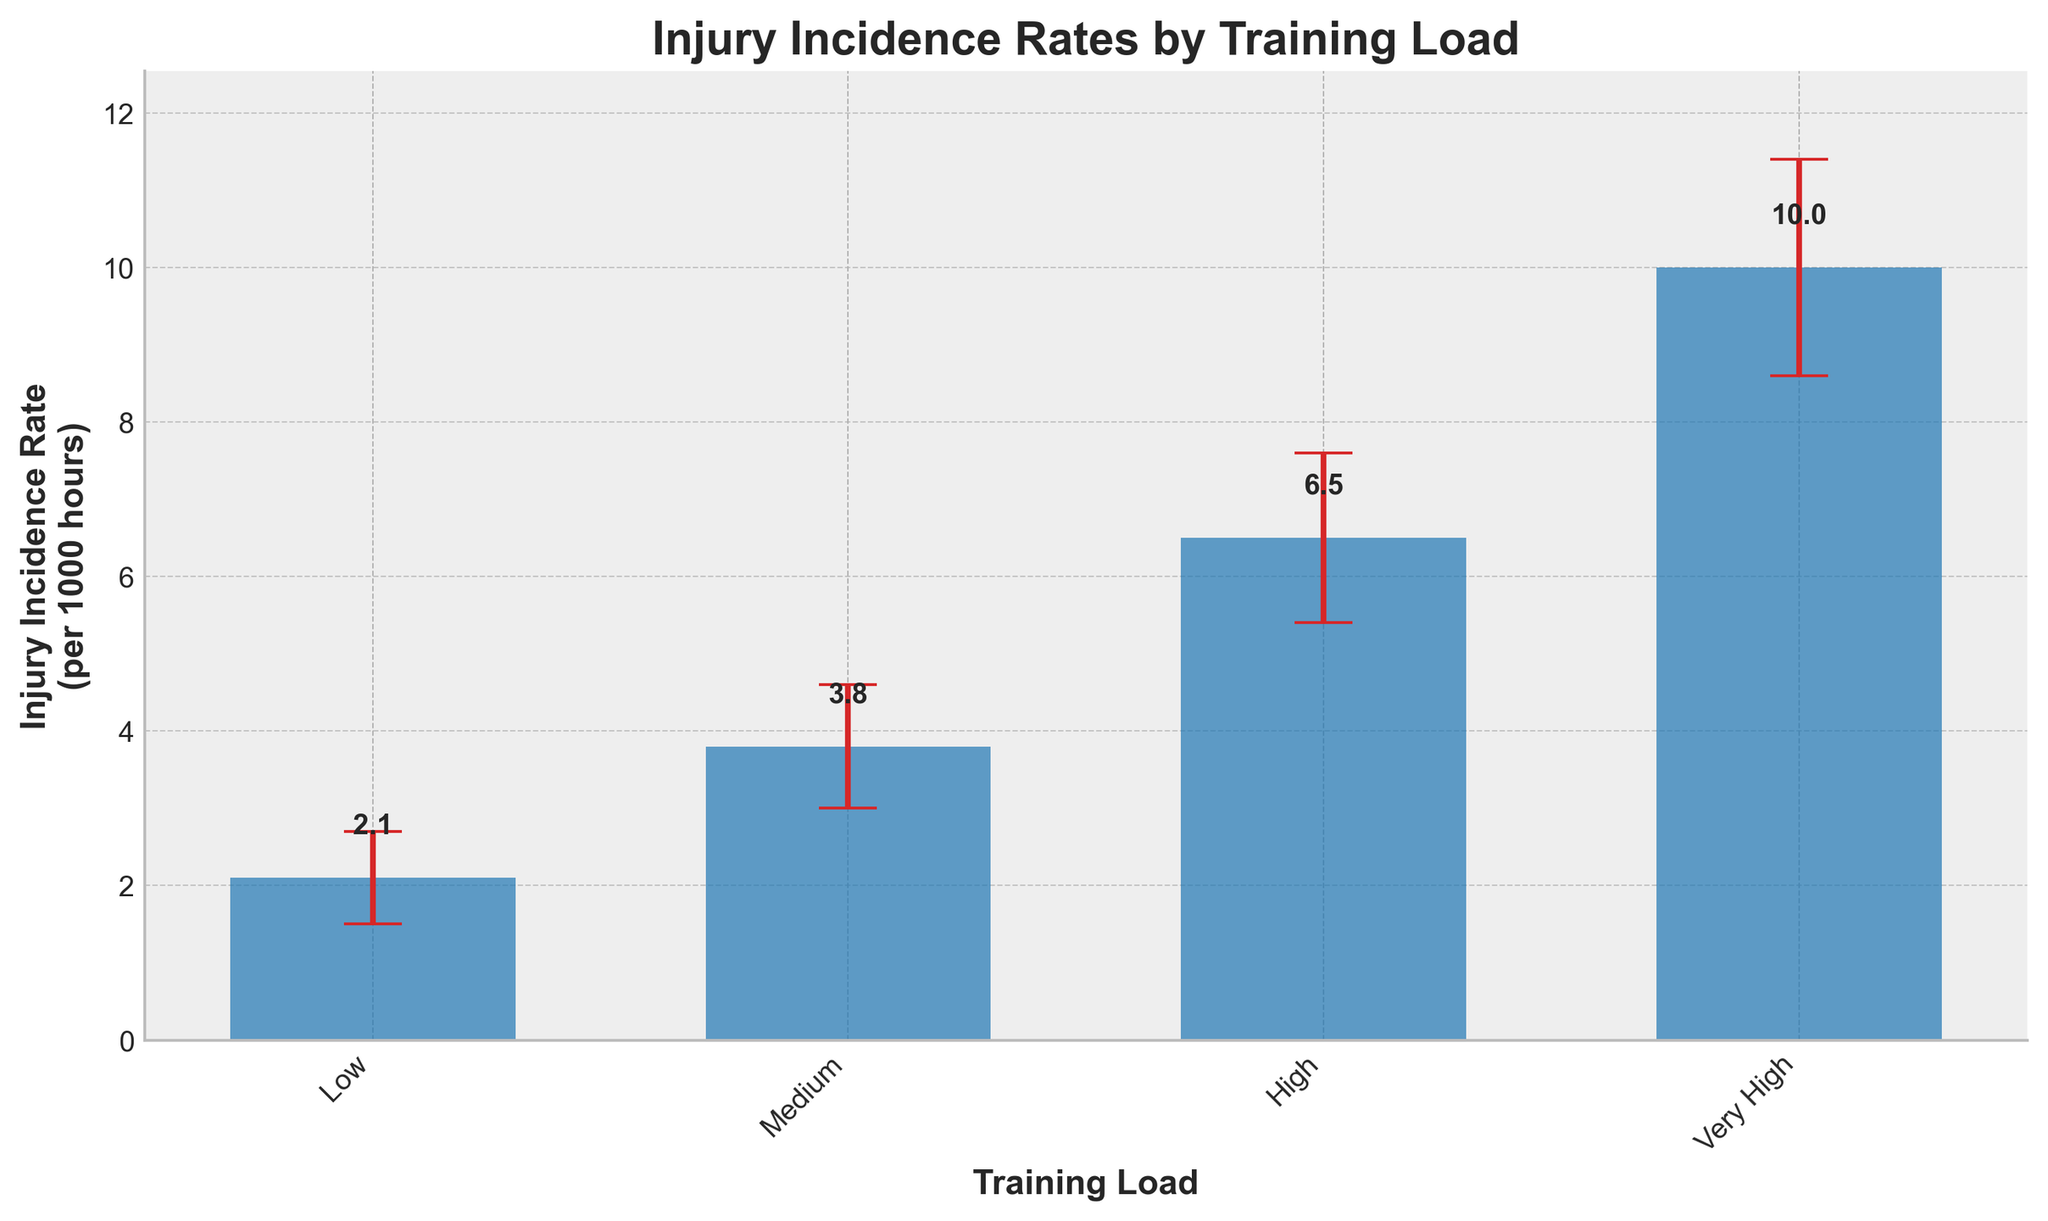What is the title of the plot? The title of the plot is located at the top and it clearly explains what the figure represents. In this case, it is "Injury Incidence Rates by Training Load".
Answer: Injury Incidence Rates by Training Load What does the y-axis represent? The y-axis label is present on the vertical line, indicating what the axis measures. Here, it is labeled "Injury Incidence Rate\n(per 1000 hours)".
Answer: Injury Incidence Rate (per 1000 hours) Which training load has the highest injury incidence rate? By looking at the height of the bars, we can see that the "Very High" training load bar is the tallest.
Answer: Very High What is the injury incidence rate for the "Medium" training load? The text on top of the bars shows the exact rates. For "Medium," it is 3.8 per 1000 hours.
Answer: 3.8 per 1000 hours By how much does the injury incidence rate increase from "Low" to "High" training load? Subtract the "Low" rate from the "High" rate using the values provided on the bars (6.5 - 2.1). This gives the increase in rate.
Answer: 4.4 per 1000 hours What is the range of the 95% confidence interval for the "High" training load? The CI can be found by subtracting the lower bound from the upper bound (7.6 - 5.4).
Answer: 2.2 How much higher is the injury incidence rate for the "Very High" training load compared to the "Medium" training load? Subtract the "Medium" rate from the "Very High" rate (10.0 - 3.8). This difference represents how much higher the rate is.
Answer: 6.2 per 1000 hours Which training load has the narrowest 95% confidence interval? Compare the range of the CI for each training load to determine the narrowest one. The "Low" training load has the narrowest CI because the range is 2.7 - 1.5 = 1.2, which is smaller than for other loads.
Answer: Low Does the injury incidence rate for "Low" training load overlap with any other training load's confidence interval? To determine overlap, compare the CI ranges for "Low" training load (1.5 to 2.7) with the CIs of other loads. None of the CIs for "Medium", "High", or "Very High" fall within this range, indicating no overlap.
Answer: No 